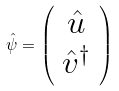<formula> <loc_0><loc_0><loc_500><loc_500>\hat { \psi } = \left ( \begin{array} { c } \hat { u } \\ \hat { v } ^ { \dagger } \end{array} \right )</formula> 